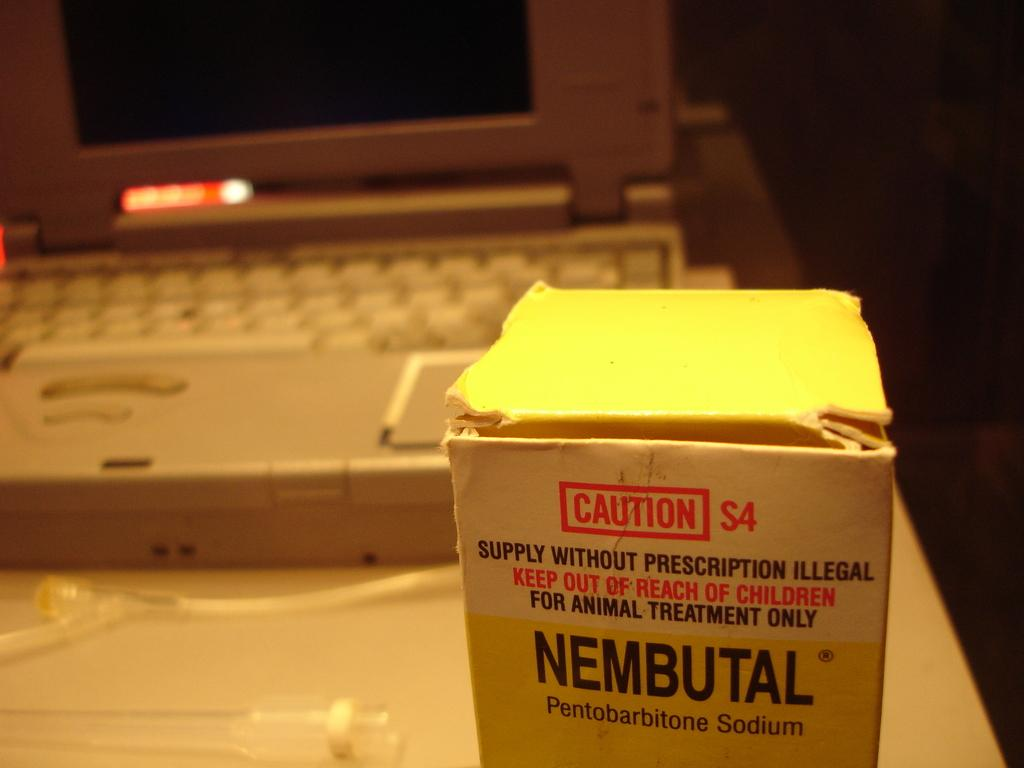Provide a one-sentence caption for the provided image. A white box of Nembutal Pentobarbitone Sodium in front of a laptop. 